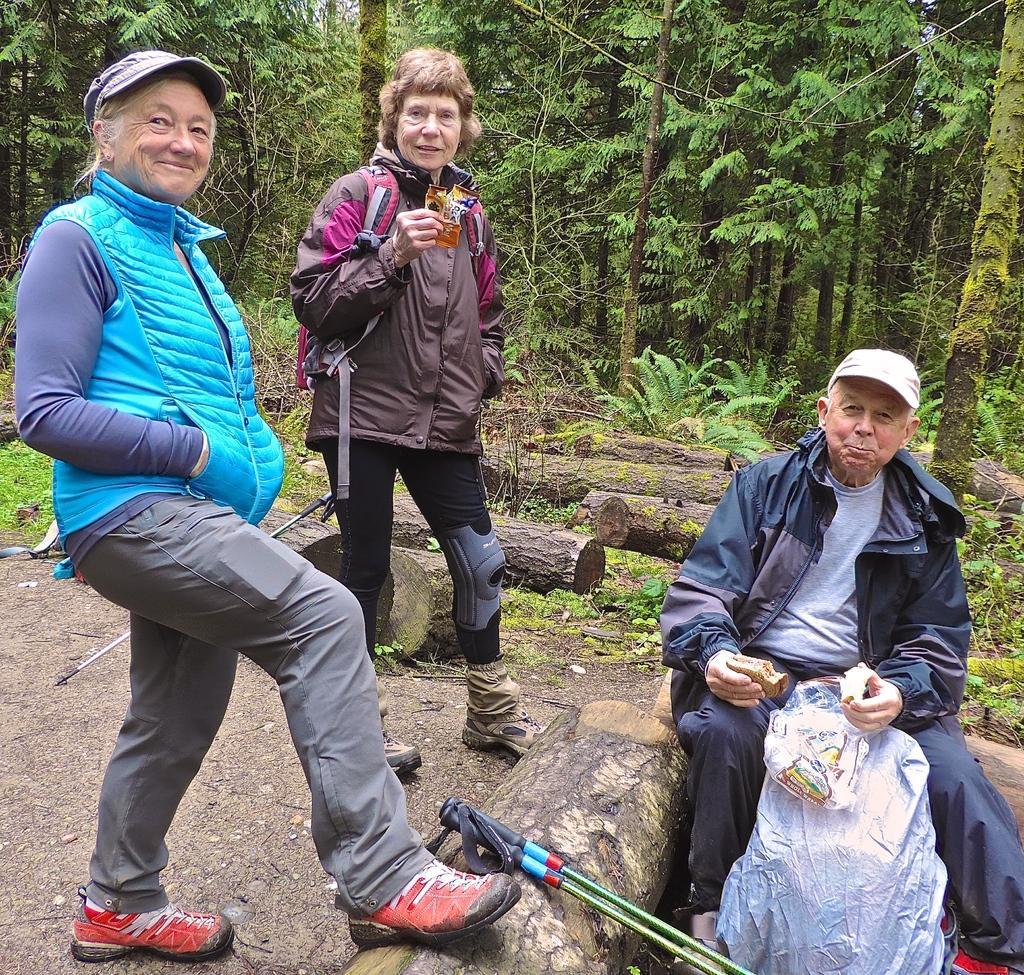In one or two sentences, can you explain what this image depicts? In this picture I can see two women are standing among them a woman is holding an object and a woman is wearing cap. The man is sitting on a wooden object and holding some objects in the hands. In the background I can see trees, plants and pieces of wood. I can also see some objects on the ground. 